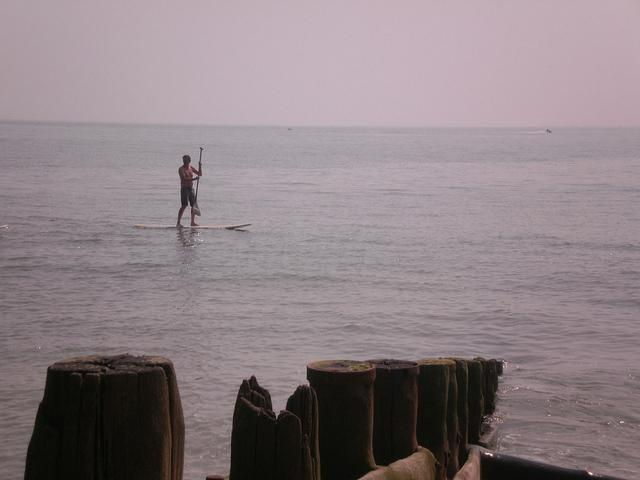Where else would his hand held tool be somewhat suitable? home 